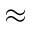<formula> <loc_0><loc_0><loc_500><loc_500>\approx</formula> 